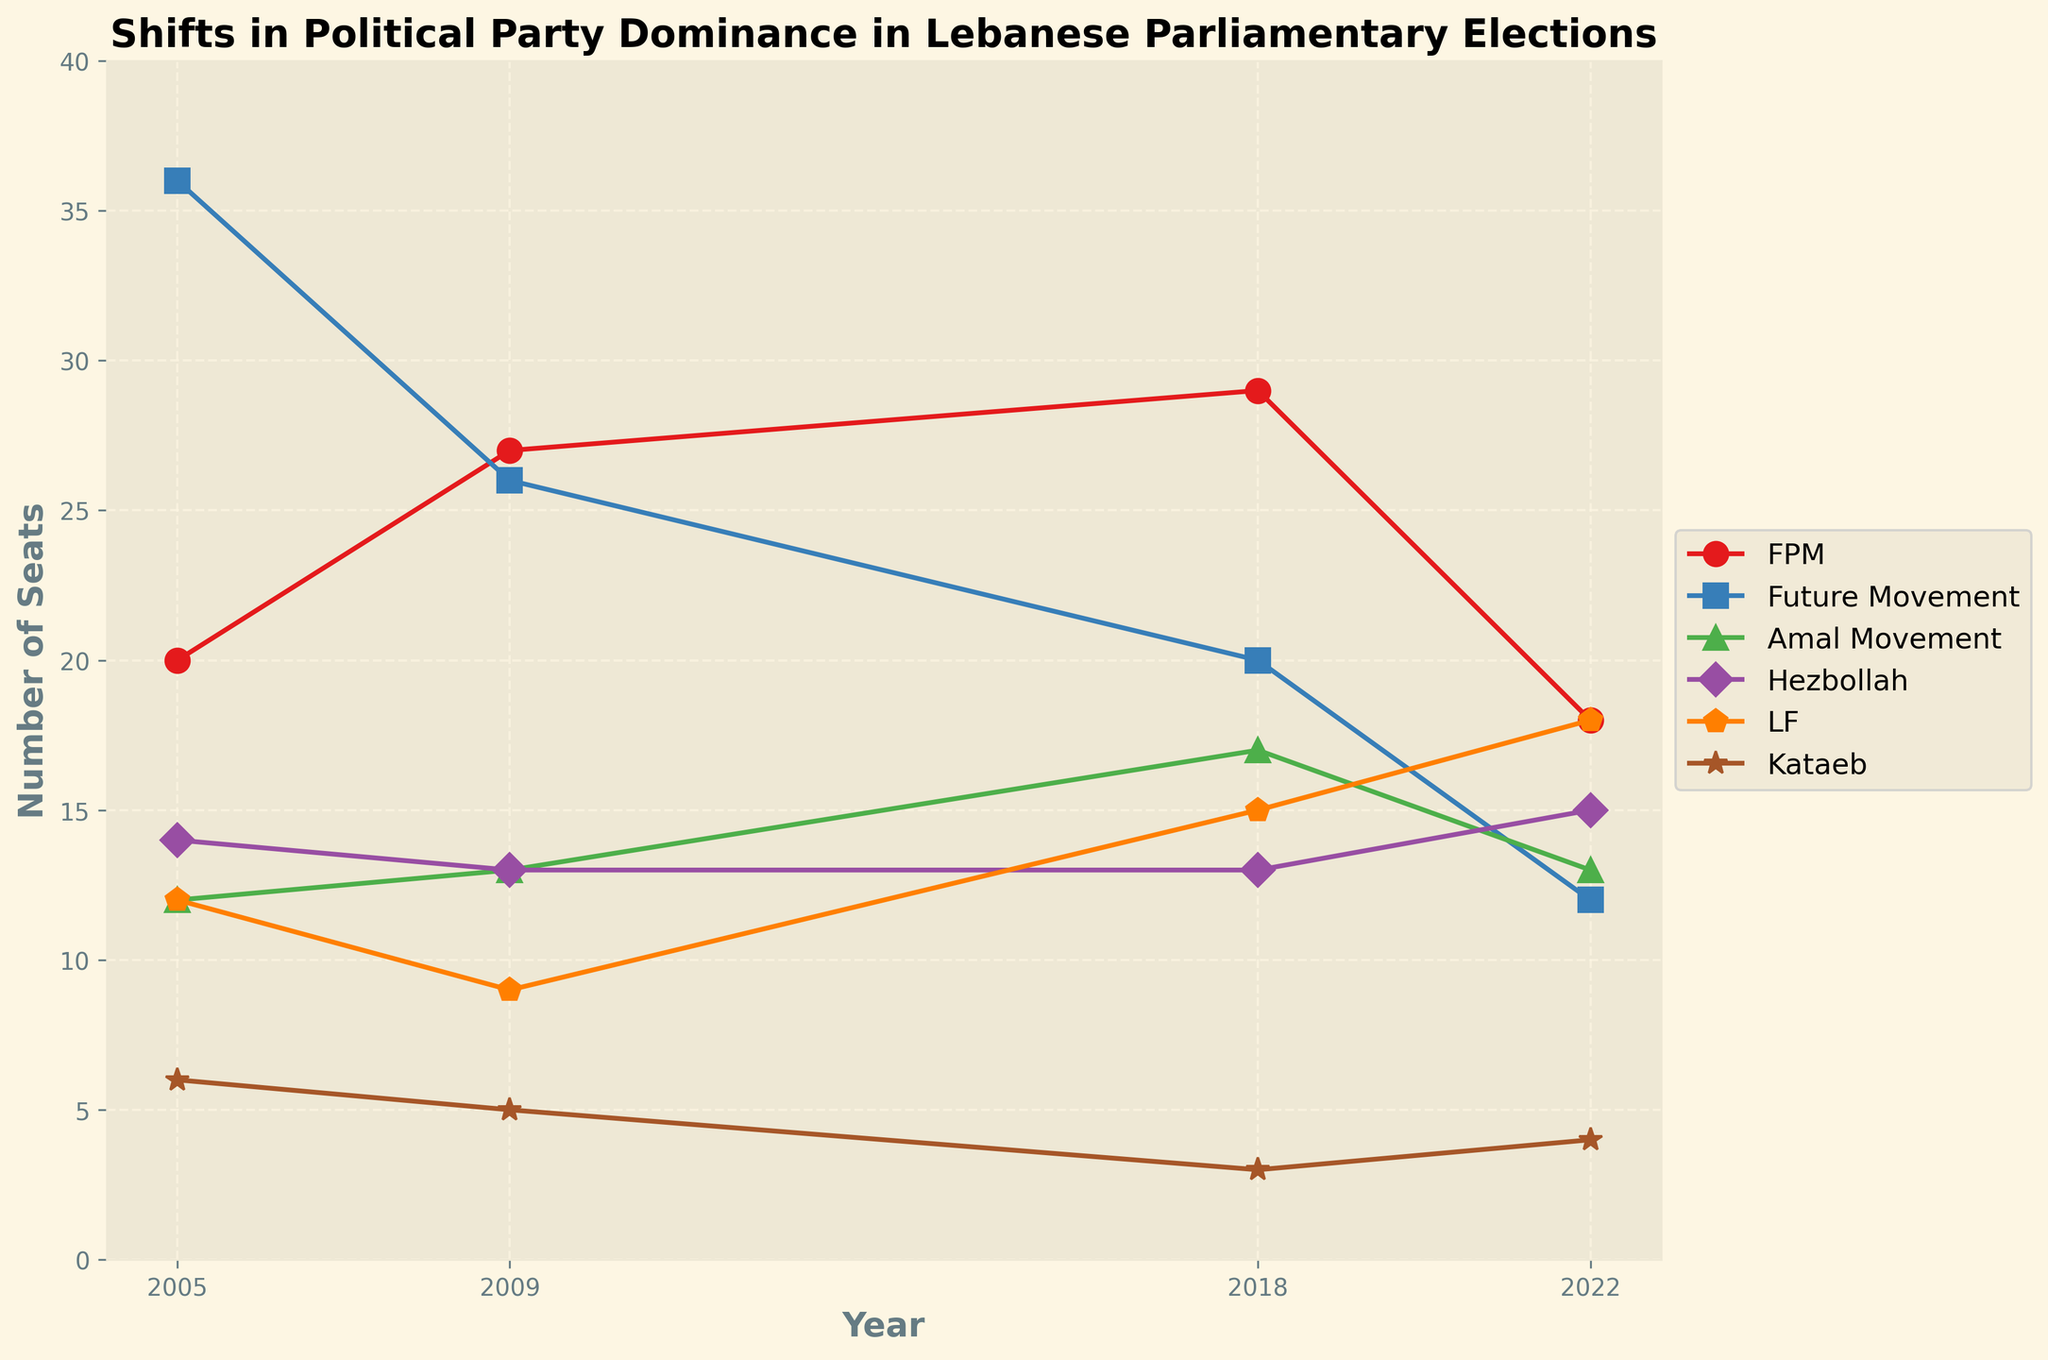What is the title of the figure? The title of the figure is displayed at the top and summarizes the main subject of the plot. It is "Shifts in Political Party Dominance in Lebanese Parliamentary Elections".
Answer: Shifts in Political Party Dominance in Lebanese Parliamentary Elections Which political party had the highest number of seats in 2005? Look at the data points in the year 2005 and find which line reaches the highest value. Future Movement has the highest number of seats.
Answer: Future Movement How many seats did Hezbollah have in 2022? Find the year 2022 on the x-axis, then look at the data point corresponding to Hezbollah's color and marker. It shows 15 seats.
Answer: 15 What is the overall trend for Future Movement from 2005 to 2022? Observe the data points connected by lines for Future Movement over the years. The trend shows a decrease from 36 seats in 2005 to 12 seats in 2022.
Answer: Decreasing trend What is the difference in the number of seats between FPM and LF in 2022? Look at the data points for FPM and LF in 2022. FPM has 18 seats and LF has 18 seats. The difference is 0.
Answer: 0 Which party experienced the largest increase in seats between 2009 and 2018? Calculate the change in seats for each party between these years and find the maximum. LF increased from 9 to 15 seats, a change of 6 seats, which is the largest increase.
Answer: LF What was the total number of seats held by the Amal Movement over the four elections? Sum the number of seats Amal Movement held in 2005 (12), 2009 (13), 2018 (17), and 2022 (13). The total is 12 + 13 + 17 + 13 = 55.
Answer: 55 Between which years did FPM see its largest drop in the number of seats? Compare the changes in FPM seats across the intervals: 2005-2009, 2009-2018, and 2018-2022. The largest drop is between 2018 (29) and 2022 (18), a decrease of 11 seats.
Answer: 2018-2022 Which two parties had equal seats in 2009? Look at the data points for all parties in 2009 and identify any that have the same value. Hezbollah and Amal Movement both had 13 seats.
Answer: Hezbollah and Amal Movement 